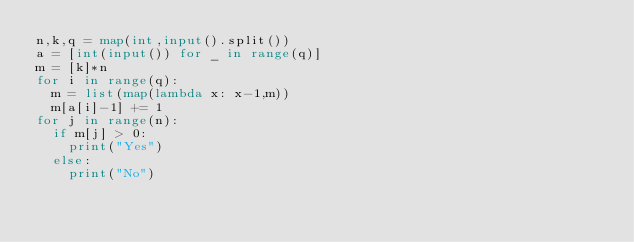Convert code to text. <code><loc_0><loc_0><loc_500><loc_500><_Python_>n,k,q = map(int,input().split())
a = [int(input()) for _ in range(q)]
m = [k]*n 
for i in range(q):
  m = list(map(lambda x: x-1,m))
  m[a[i]-1] += 1
for j in range(n):
  if m[j] > 0:
    print("Yes")
  else:
    print("No")</code> 